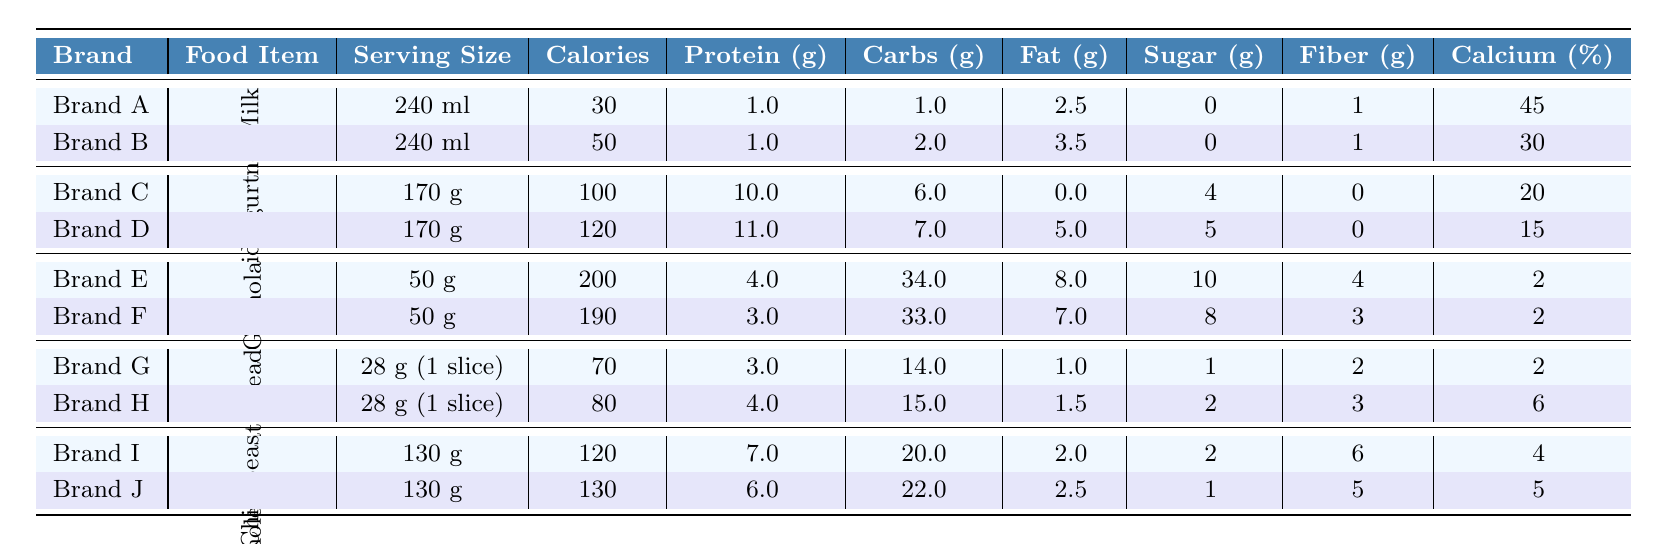What is the calorie content of Brand A's Organic Almond Milk? The table lists Brand A's Organic Almond Milk with a calorie content of 30 for a serving size of 240 ml.
Answer: 30 Which food item has the highest protein content per serving? By reviewing the protein content for each food item, Greek Yogurt from Brand C has the highest at 10 g per 170 g serving.
Answer: 10 g How many grams of fat does Brand D's Greek Yogurt contain? The table shows that Brand D's Greek Yogurt has 5 g of fat for a serving size of 170 g.
Answer: 5 g What is the total carbohydrate content in the Granola from Brand E? The table states that Brand E's Granola has 34 g of carbohydrates for a serving size of 50 g.
Answer: 34 g Is the sugar content in Brand F's Granola lower than in Brand E's Granola? Brand F's Granola has 8 g of sugar while Brand E's Granola has 10 g, so the sugar content in Brand F is lower.
Answer: Yes What is the difference in calorie content between Brand G's and Brand H's Whole Wheat Bread? Brand G's Whole Wheat Bread has 70 calories and Brand H's has 80 calories. The difference is 80 - 70 = 10 calories.
Answer: 10 calories Calculate the average protein content of the two brands of Canned Chickpeas. Brand I has 7 g of protein and Brand J has 6 g. The average is (7 + 6) / 2 = 6.5 g.
Answer: 6.5 g Which brand of Greek Yogurt has the lower calcium percentage? Comparing the calcium percentages, Brand D's Greek Yogurt has 15%, which is lower than Brand C's 20%.
Answer: Brand D Does Brand B's Almond Milk have a higher caloric value than the average of both almond milk brands? Brand A has 30 calories and Brand B has 50 calories. The average is (30 + 50) / 2 = 40 calories. Brand B has a higher caloric value than the average of 40.
Answer: Yes What is the sugar content of the Canned Chickpeas from Brand J? The table indicates that Brand J's Canned Chickpeas contains 1 g of sugar for a serving size of 130 g.
Answer: 1 g 